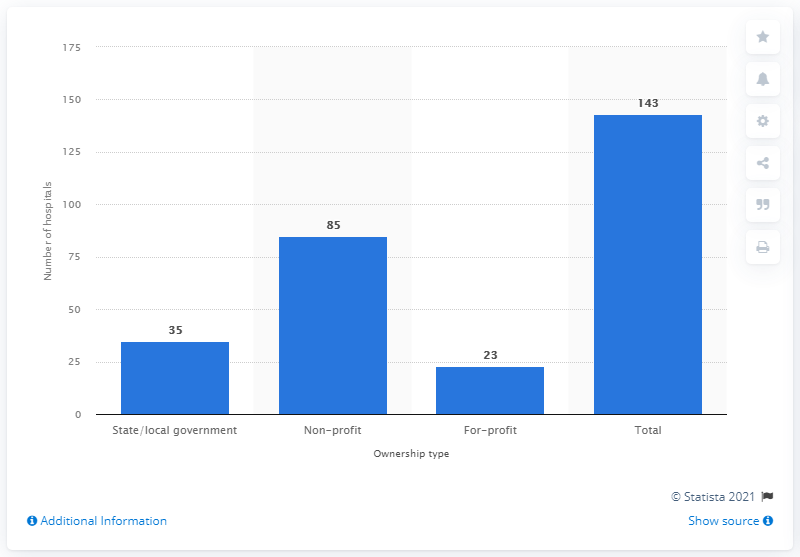Highlight a few significant elements in this photo. In 2019, there were 143 hospitals operating in the state of Georgia. 